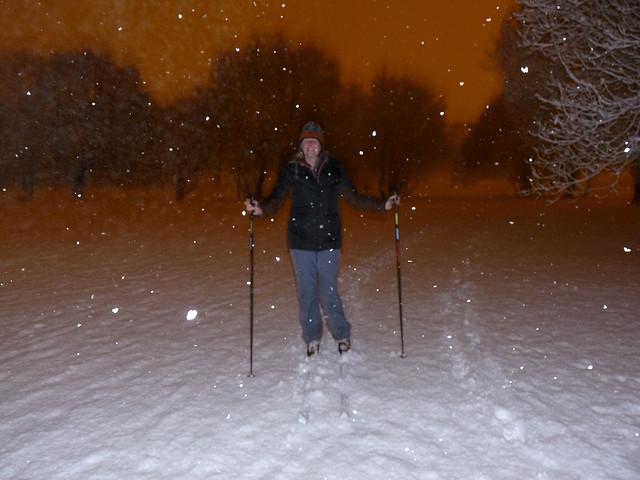What time of day is it?
Keep it brief. Night. Is the color of the environment behind the person natural looking for this environment?
Give a very brief answer. Yes. What is the woman holding?
Be succinct. Ski poles. Should this woman while it is actively snowing?
Write a very short answer. No. 